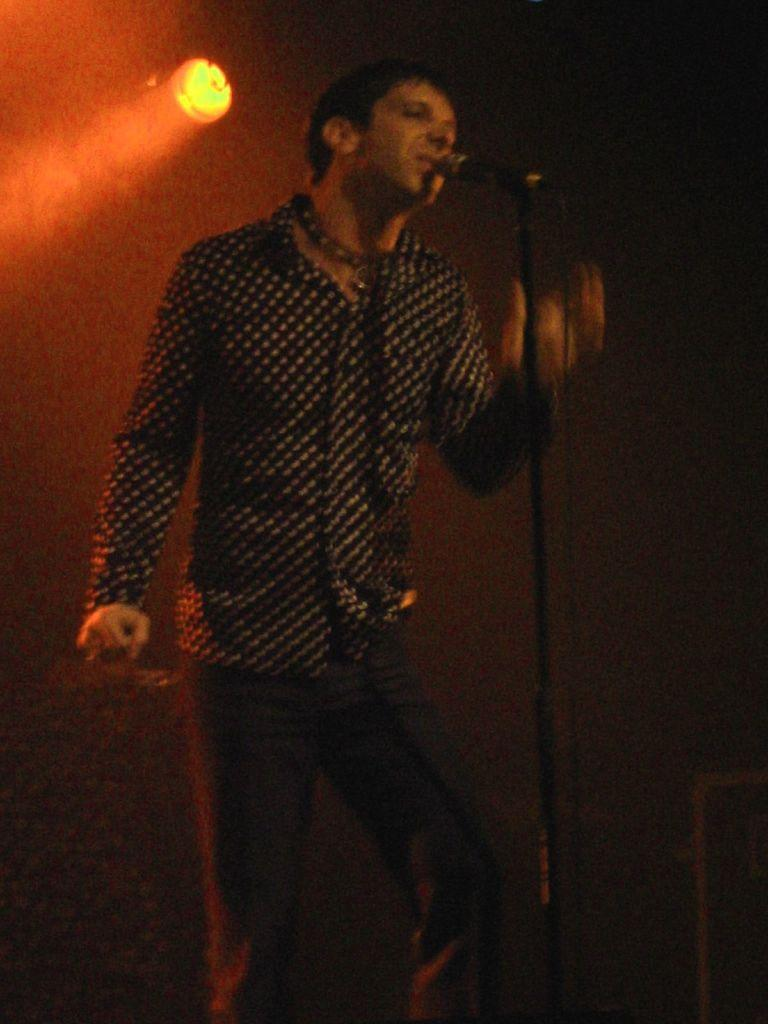What is the main subject of the image? There is a man in the image. What is the man doing in the image? The man is standing and singing a song. What object is the man holding in the image? The man is holding a microphone. What is the man wearing in the image? The man is wearing a black shirt. Can you describe the design of the black shirt? The black shirt has black dots on it. What can be seen behind the man in the image? There is a light visible behind the man. What type of carriage can be seen in the image? There is no carriage present in the image. What color are the man's shoes in the image? The provided facts do not mention the man's shoes, so we cannot determine their color from the image. 